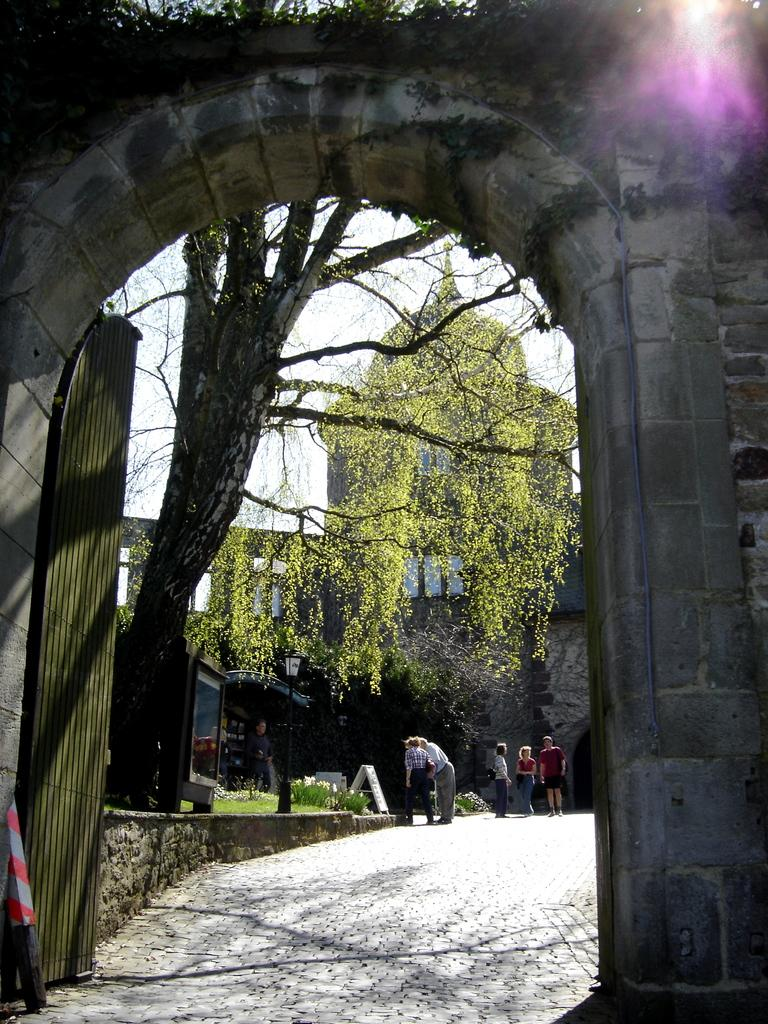What type of structure is present in the image? There is a stone arch in the image. What is located near the stone arch? There is a gate in the image. What can be seen on the road in the image? There are people standing on the road in the image. What is visible in the background of the image? There is a building, trees, and the sky visible in the background of the image. Where is the playground located in the image? There is no playground present in the image. What type of love is depicted in the image? There is no depiction of love in the image; it features a stone arch, a gate, people on the road, and background elements. 